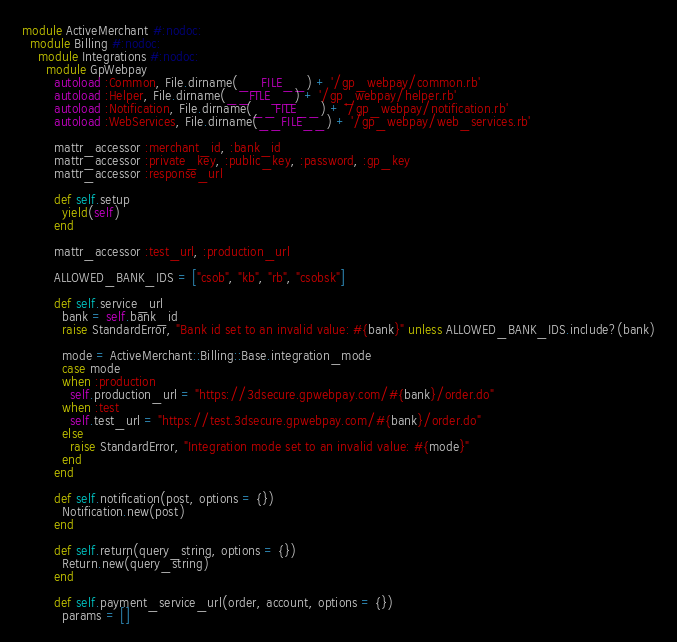Convert code to text. <code><loc_0><loc_0><loc_500><loc_500><_Ruby_>module ActiveMerchant #:nodoc:
  module Billing #:nodoc:
    module Integrations #:nodoc:
      module GpWebpay 
        autoload :Common, File.dirname(__FILE__) + '/gp_webpay/common.rb'
        autoload :Helper, File.dirname(__FILE__) + '/gp_webpay/helper.rb'
        autoload :Notification, File.dirname(__FILE__) + '/gp_webpay/notification.rb'
        autoload :WebServices, File.dirname(__FILE__) + '/gp_webpay/web_services.rb'

        mattr_accessor :merchant_id, :bank_id
        mattr_accessor :private_key, :public_key, :password, :gp_key
        mattr_accessor :response_url

        def self.setup
          yield(self)
        end

        mattr_accessor :test_url, :production_url

        ALLOWED_BANK_IDS = ["csob", "kb", "rb", "csobsk"]

        def self.service_url
          bank = self.bank_id
          raise StandardError, "Bank id set to an invalid value: #{bank}" unless ALLOWED_BANK_IDS.include?(bank)

          mode = ActiveMerchant::Billing::Base.integration_mode
          case mode
          when :production
            self.production_url = "https://3dsecure.gpwebpay.com/#{bank}/order.do"
          when :test
            self.test_url = "https://test.3dsecure.gpwebpay.com/#{bank}/order.do"
          else
            raise StandardError, "Integration mode set to an invalid value: #{mode}"
          end
        end

        def self.notification(post, options = {})
          Notification.new(post)
        end  

        def self.return(query_string, options = {})
          Return.new(query_string)
        end

        def self.payment_service_url(order, account, options = {})
          params = []</code> 